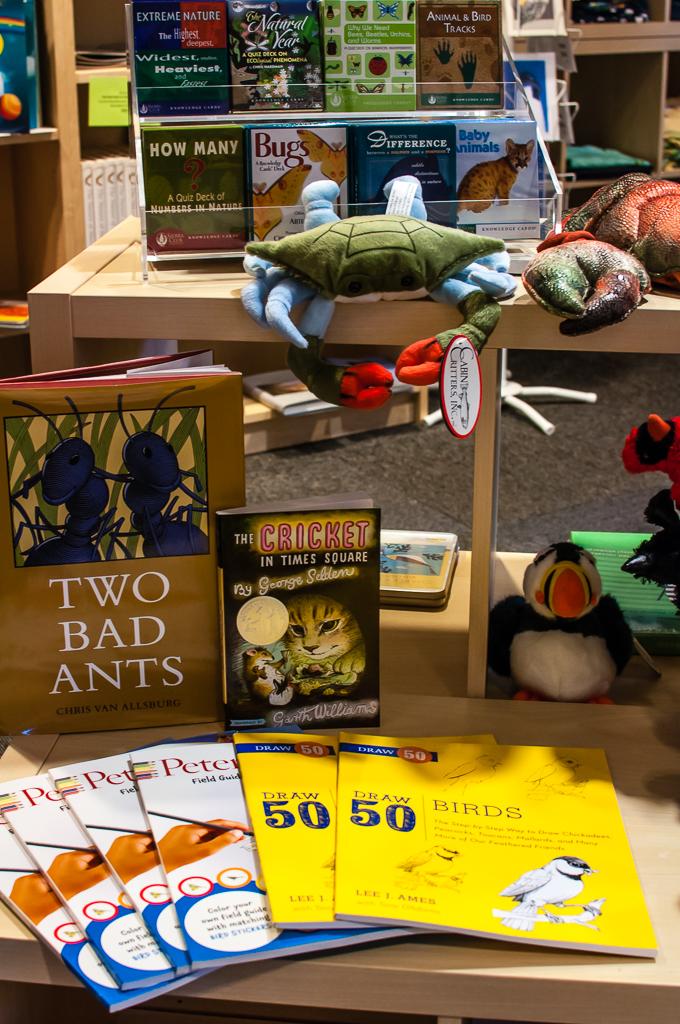What is the title of the book?
Provide a succinct answer. Two bad ants. What is the magazine on the bottom right called?
Your response must be concise. Birds. 